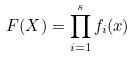Convert formula to latex. <formula><loc_0><loc_0><loc_500><loc_500>F ( X ) = \prod _ { i = 1 } ^ { s } f _ { i } ( x )</formula> 